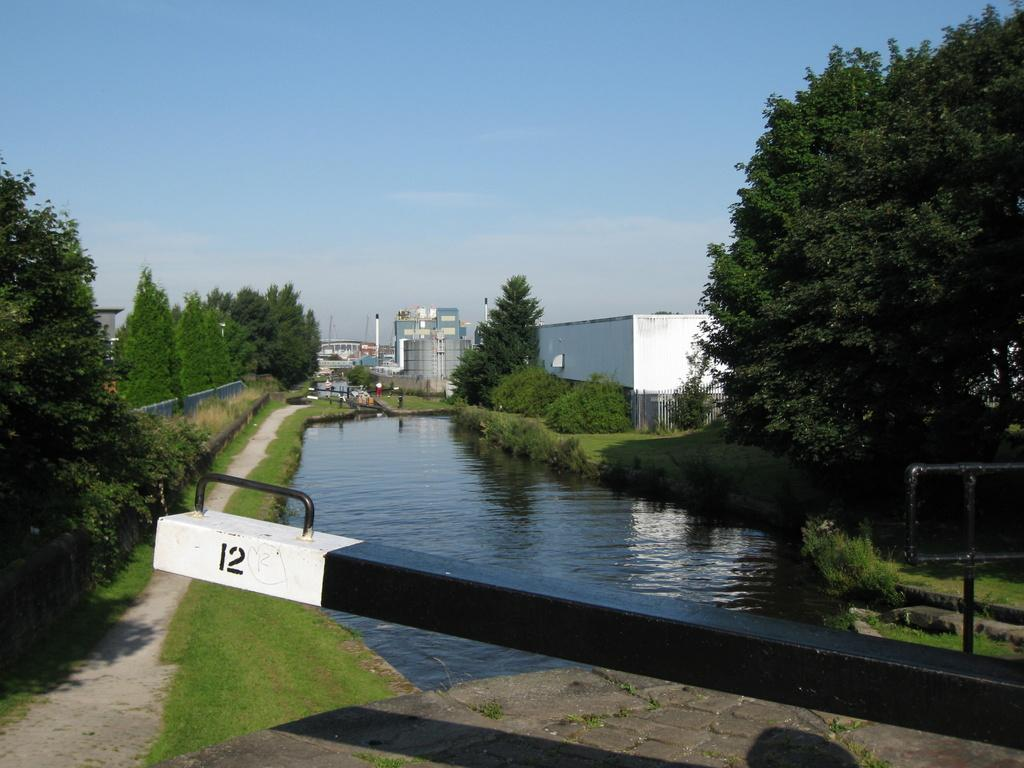What type of water feature is present in the image? There is a water canal in the image. What can be seen on both sides of the canal? There are trees on either side of the canal. What type of structures are visible in the image? There are buildings visible in the image. How would you describe the sky in the image? The sky is blue and cloudy. How many pies are stacked on the books in the image? There are no pies or books present in the image. What type of discovery was made near the water canal in the image? There is no mention of a discovery in the image; it only features a water canal, trees, buildings, and a blue and cloudy sky. 